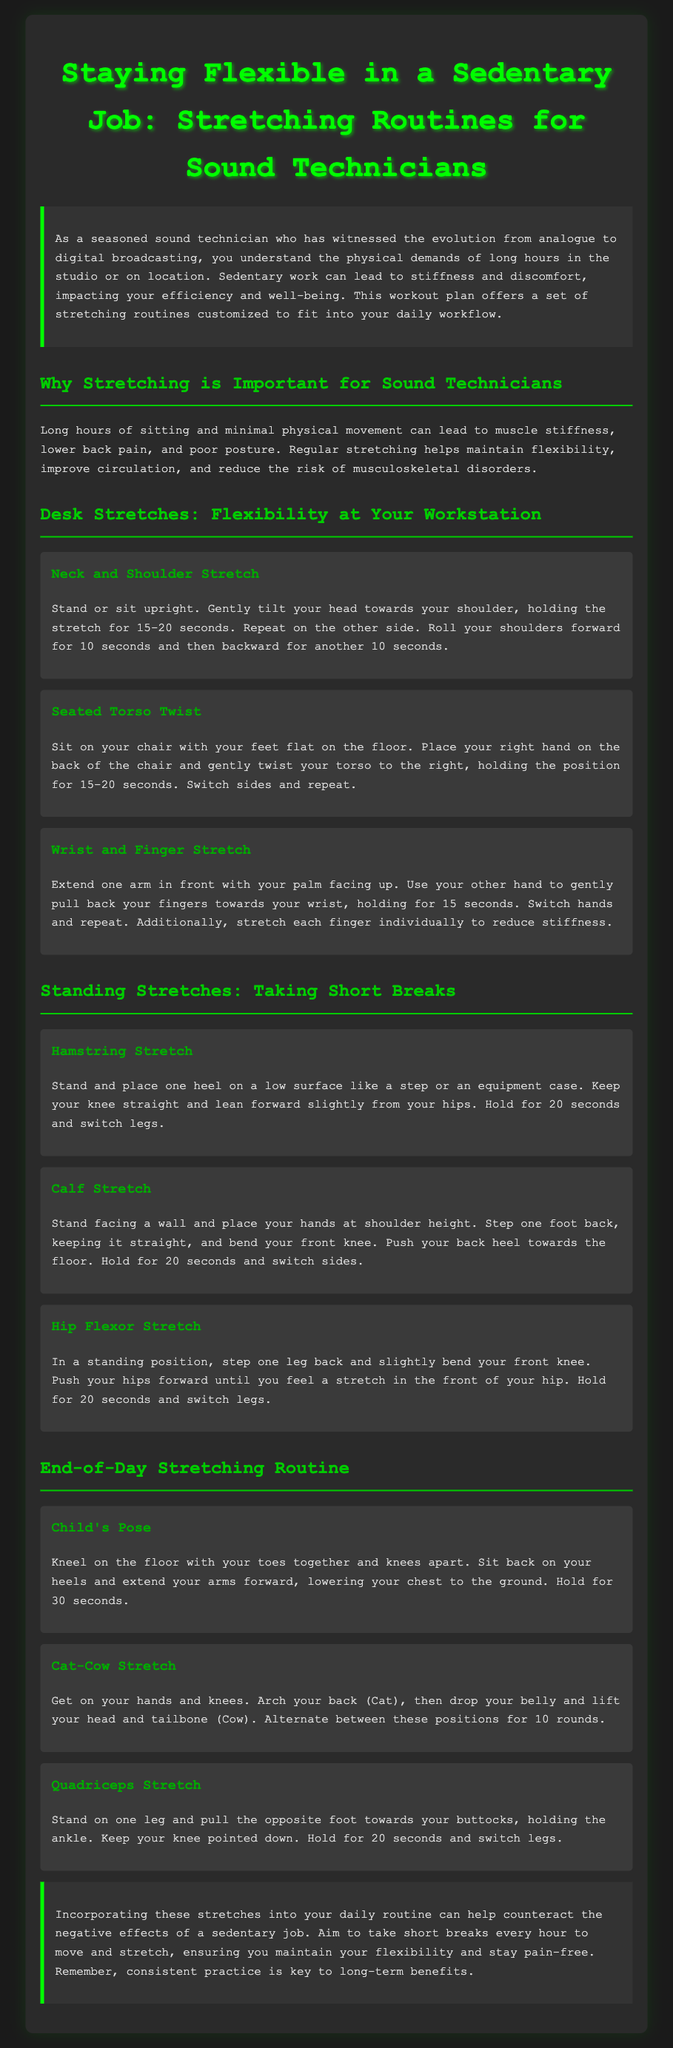What is the title of the document? The title is prominently displayed at the top of the document.
Answer: Staying Flexible in a Sedentary Job: Stretching Routines for Sound Technicians What is the recommended hold time for the Neck and Shoulder Stretch? The stretching routine specifies the duration for this stretch.
Answer: 15-20 seconds How many standing stretches are listed in the document? The document outlines several stretches under the standing stretches section, counting them provides the answer.
Answer: 3 What does the Child's Pose stretch target? The name of the stretch suggests its benefits and purpose.
Answer: Flexibility and relaxation How often should you take breaks to stretch? The conclusion suggests a frequency for taking breaks during the workday.
Answer: Every hour What is the purpose of the stretching routines? The introduction clarifies the main goal of the document.
Answer: To maintain flexibility and reduce discomfort Which stretch involves twisting the torso? The document names specific stretches, and one is explicitly dedicated to this action.
Answer: Seated Torso Twist What type of injury do regular stretches help prevent? The document explains the health benefits related to stretching that counteract certain injuries.
Answer: Musculoskeletal disorders What is the last stretching routine mentioned in the document? The last section lists the stretches, providing an easy way to identify the last one mentioned.
Answer: Quadriceps Stretch 